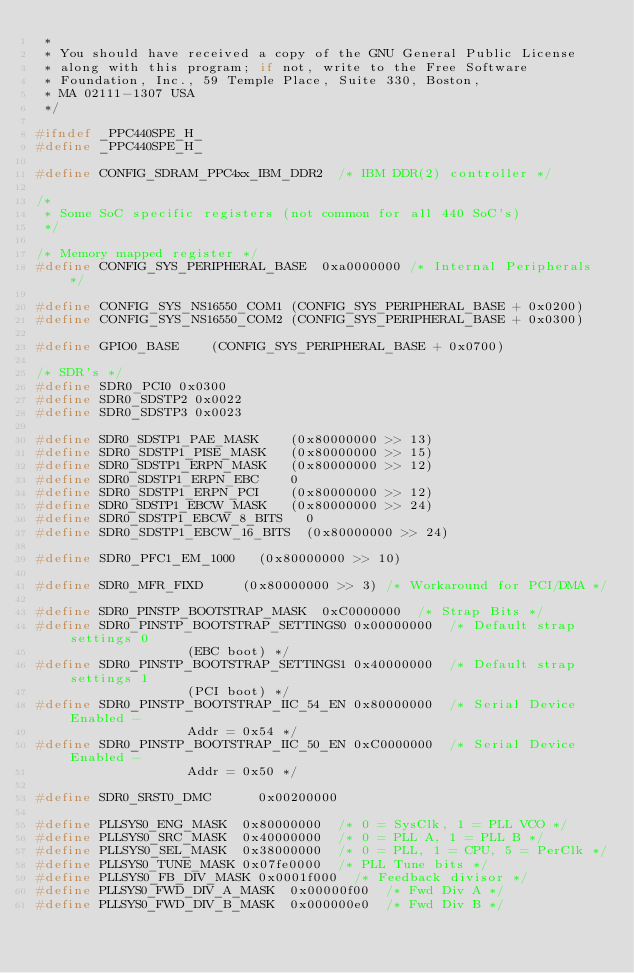<code> <loc_0><loc_0><loc_500><loc_500><_C_> *
 * You should have received a copy of the GNU General Public License
 * along with this program; if not, write to the Free Software
 * Foundation, Inc., 59 Temple Place, Suite 330, Boston,
 * MA 02111-1307 USA
 */

#ifndef _PPC440SPE_H_
#define _PPC440SPE_H_

#define CONFIG_SDRAM_PPC4xx_IBM_DDR2	/* IBM DDR(2) controller */

/*
 * Some SoC specific registers (not common for all 440 SoC's)
 */

/* Memory mapped register */
#define CONFIG_SYS_PERIPHERAL_BASE	0xa0000000 /* Internal Peripherals */

#define CONFIG_SYS_NS16550_COM1	(CONFIG_SYS_PERIPHERAL_BASE + 0x0200)
#define CONFIG_SYS_NS16550_COM2	(CONFIG_SYS_PERIPHERAL_BASE + 0x0300)

#define GPIO0_BASE		(CONFIG_SYS_PERIPHERAL_BASE + 0x0700)

/* SDR's */
#define SDR0_PCI0	0x0300
#define SDR0_SDSTP2	0x0022
#define SDR0_SDSTP3	0x0023

#define SDR0_SDSTP1_PAE_MASK		(0x80000000 >> 13)
#define SDR0_SDSTP1_PISE_MASK		(0x80000000 >> 15)
#define SDR0_SDSTP1_ERPN_MASK		(0x80000000 >> 12)
#define SDR0_SDSTP1_ERPN_EBC		0
#define SDR0_SDSTP1_ERPN_PCI		(0x80000000 >> 12)
#define SDR0_SDSTP1_EBCW_MASK		(0x80000000 >> 24)
#define SDR0_SDSTP1_EBCW_8_BITS		0
#define SDR0_SDSTP1_EBCW_16_BITS	(0x80000000 >> 24)

#define SDR0_PFC1_EM_1000		(0x80000000 >> 10)

#define SDR0_MFR_FIXD			(0x80000000 >> 3)	/* Workaround for PCI/DMA */

#define SDR0_PINSTP_BOOTSTRAP_MASK	0xC0000000  /* Strap Bits */
#define SDR0_PINSTP_BOOTSTRAP_SETTINGS0	0x00000000  /* Default strap settings 0
						       (EBC boot) */
#define SDR0_PINSTP_BOOTSTRAP_SETTINGS1	0x40000000  /* Default strap settings 1
						       (PCI boot) */
#define SDR0_PINSTP_BOOTSTRAP_IIC_54_EN	0x80000000  /* Serial Device Enabled -
						       Addr = 0x54 */
#define SDR0_PINSTP_BOOTSTRAP_IIC_50_EN	0xC0000000  /* Serial Device Enabled -
						       Addr = 0x50 */

#define SDR0_SRST0_DMC			0x00200000

#define PLLSYS0_ENG_MASK	0x80000000	/* 0 = SysClk, 1 = PLL VCO */
#define PLLSYS0_SRC_MASK	0x40000000	/* 0 = PLL A, 1 = PLL B */
#define PLLSYS0_SEL_MASK	0x38000000	/* 0 = PLL, 1 = CPU, 5 = PerClk */
#define PLLSYS0_TUNE_MASK	0x07fe0000	/* PLL Tune bits */
#define PLLSYS0_FB_DIV_MASK	0x0001f000	/* Feedback divisor */
#define PLLSYS0_FWD_DIV_A_MASK	0x00000f00	/* Fwd Div A */
#define PLLSYS0_FWD_DIV_B_MASK	0x000000e0	/* Fwd Div B */</code> 